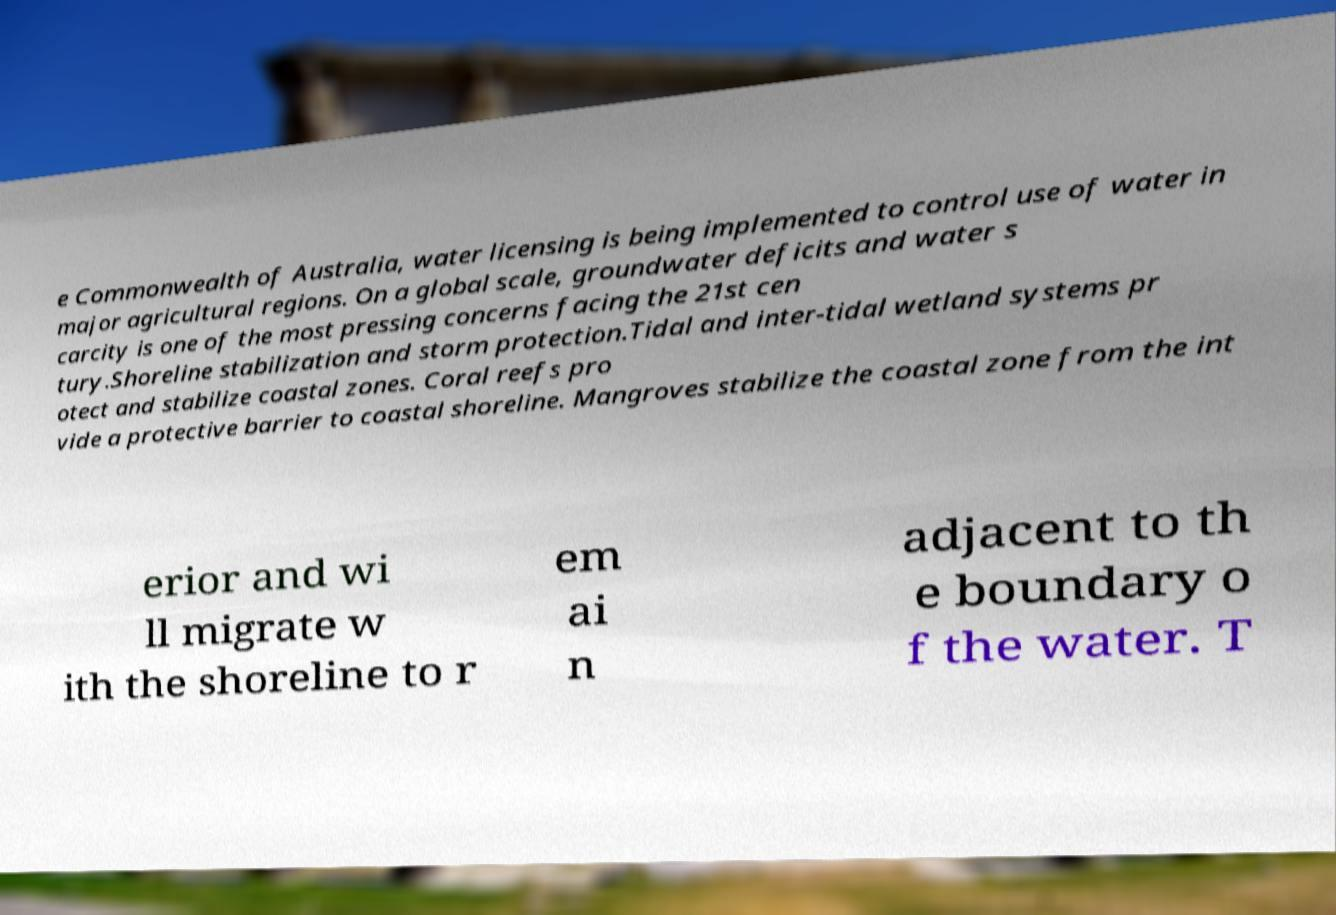I need the written content from this picture converted into text. Can you do that? e Commonwealth of Australia, water licensing is being implemented to control use of water in major agricultural regions. On a global scale, groundwater deficits and water s carcity is one of the most pressing concerns facing the 21st cen tury.Shoreline stabilization and storm protection.Tidal and inter-tidal wetland systems pr otect and stabilize coastal zones. Coral reefs pro vide a protective barrier to coastal shoreline. Mangroves stabilize the coastal zone from the int erior and wi ll migrate w ith the shoreline to r em ai n adjacent to th e boundary o f the water. T 